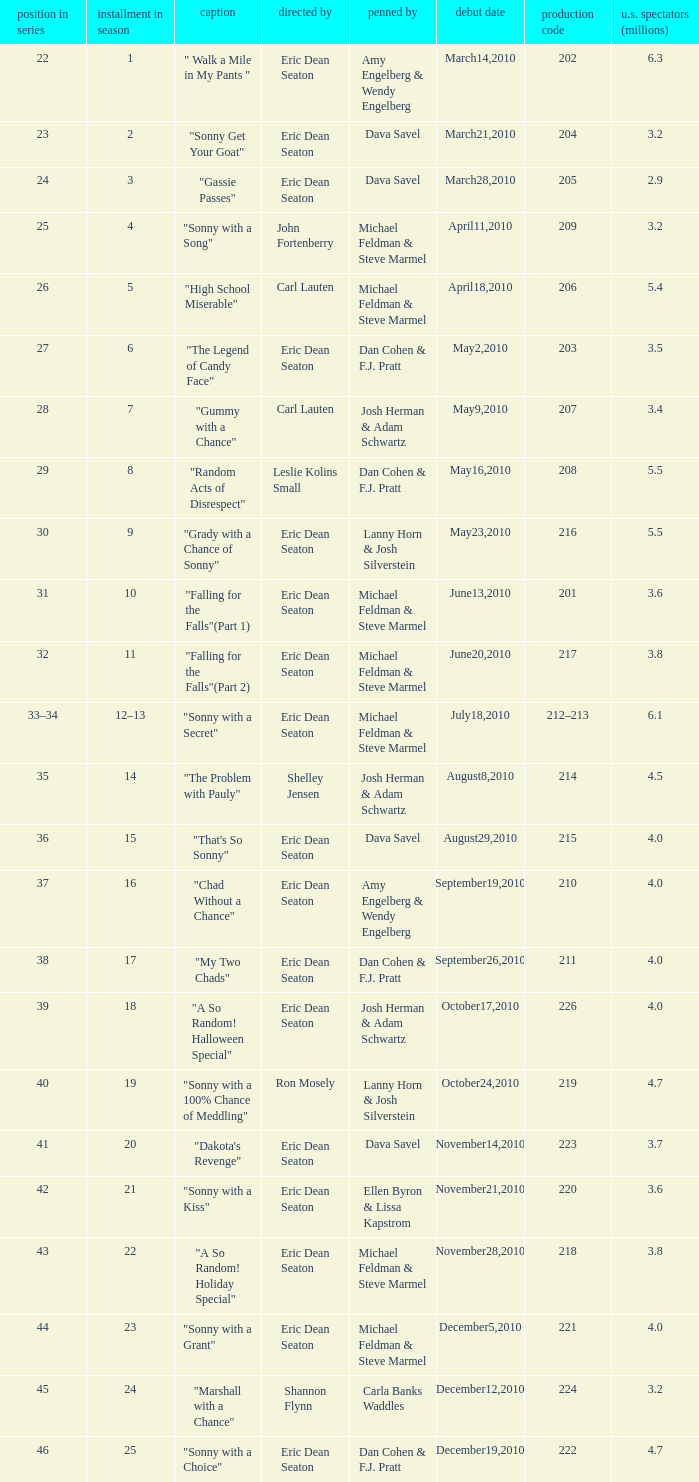How man episodes in the season were titled "that's so sonny"? 1.0. Would you be able to parse every entry in this table? {'header': ['position in series', 'installment in season', 'caption', 'directed by', 'penned by', 'debut date', 'production code', 'u.s. spectators (millions)'], 'rows': [['22', '1', '" Walk a Mile in My Pants "', 'Eric Dean Seaton', 'Amy Engelberg & Wendy Engelberg', 'March14,2010', '202', '6.3'], ['23', '2', '"Sonny Get Your Goat"', 'Eric Dean Seaton', 'Dava Savel', 'March21,2010', '204', '3.2'], ['24', '3', '"Gassie Passes"', 'Eric Dean Seaton', 'Dava Savel', 'March28,2010', '205', '2.9'], ['25', '4', '"Sonny with a Song"', 'John Fortenberry', 'Michael Feldman & Steve Marmel', 'April11,2010', '209', '3.2'], ['26', '5', '"High School Miserable"', 'Carl Lauten', 'Michael Feldman & Steve Marmel', 'April18,2010', '206', '5.4'], ['27', '6', '"The Legend of Candy Face"', 'Eric Dean Seaton', 'Dan Cohen & F.J. Pratt', 'May2,2010', '203', '3.5'], ['28', '7', '"Gummy with a Chance"', 'Carl Lauten', 'Josh Herman & Adam Schwartz', 'May9,2010', '207', '3.4'], ['29', '8', '"Random Acts of Disrespect"', 'Leslie Kolins Small', 'Dan Cohen & F.J. Pratt', 'May16,2010', '208', '5.5'], ['30', '9', '"Grady with a Chance of Sonny"', 'Eric Dean Seaton', 'Lanny Horn & Josh Silverstein', 'May23,2010', '216', '5.5'], ['31', '10', '"Falling for the Falls"(Part 1)', 'Eric Dean Seaton', 'Michael Feldman & Steve Marmel', 'June13,2010', '201', '3.6'], ['32', '11', '"Falling for the Falls"(Part 2)', 'Eric Dean Seaton', 'Michael Feldman & Steve Marmel', 'June20,2010', '217', '3.8'], ['33–34', '12–13', '"Sonny with a Secret"', 'Eric Dean Seaton', 'Michael Feldman & Steve Marmel', 'July18,2010', '212–213', '6.1'], ['35', '14', '"The Problem with Pauly"', 'Shelley Jensen', 'Josh Herman & Adam Schwartz', 'August8,2010', '214', '4.5'], ['36', '15', '"That\'s So Sonny"', 'Eric Dean Seaton', 'Dava Savel', 'August29,2010', '215', '4.0'], ['37', '16', '"Chad Without a Chance"', 'Eric Dean Seaton', 'Amy Engelberg & Wendy Engelberg', 'September19,2010', '210', '4.0'], ['38', '17', '"My Two Chads"', 'Eric Dean Seaton', 'Dan Cohen & F.J. Pratt', 'September26,2010', '211', '4.0'], ['39', '18', '"A So Random! Halloween Special"', 'Eric Dean Seaton', 'Josh Herman & Adam Schwartz', 'October17,2010', '226', '4.0'], ['40', '19', '"Sonny with a 100% Chance of Meddling"', 'Ron Mosely', 'Lanny Horn & Josh Silverstein', 'October24,2010', '219', '4.7'], ['41', '20', '"Dakota\'s Revenge"', 'Eric Dean Seaton', 'Dava Savel', 'November14,2010', '223', '3.7'], ['42', '21', '"Sonny with a Kiss"', 'Eric Dean Seaton', 'Ellen Byron & Lissa Kapstrom', 'November21,2010', '220', '3.6'], ['43', '22', '"A So Random! Holiday Special"', 'Eric Dean Seaton', 'Michael Feldman & Steve Marmel', 'November28,2010', '218', '3.8'], ['44', '23', '"Sonny with a Grant"', 'Eric Dean Seaton', 'Michael Feldman & Steve Marmel', 'December5,2010', '221', '4.0'], ['45', '24', '"Marshall with a Chance"', 'Shannon Flynn', 'Carla Banks Waddles', 'December12,2010', '224', '3.2'], ['46', '25', '"Sonny with a Choice"', 'Eric Dean Seaton', 'Dan Cohen & F.J. Pratt', 'December19,2010', '222', '4.7']]} 